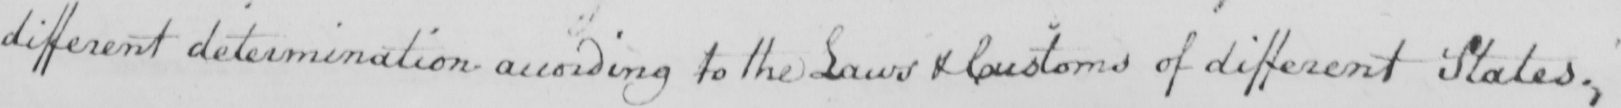Can you read and transcribe this handwriting? different determination according to the Laws & Customs of different States . 